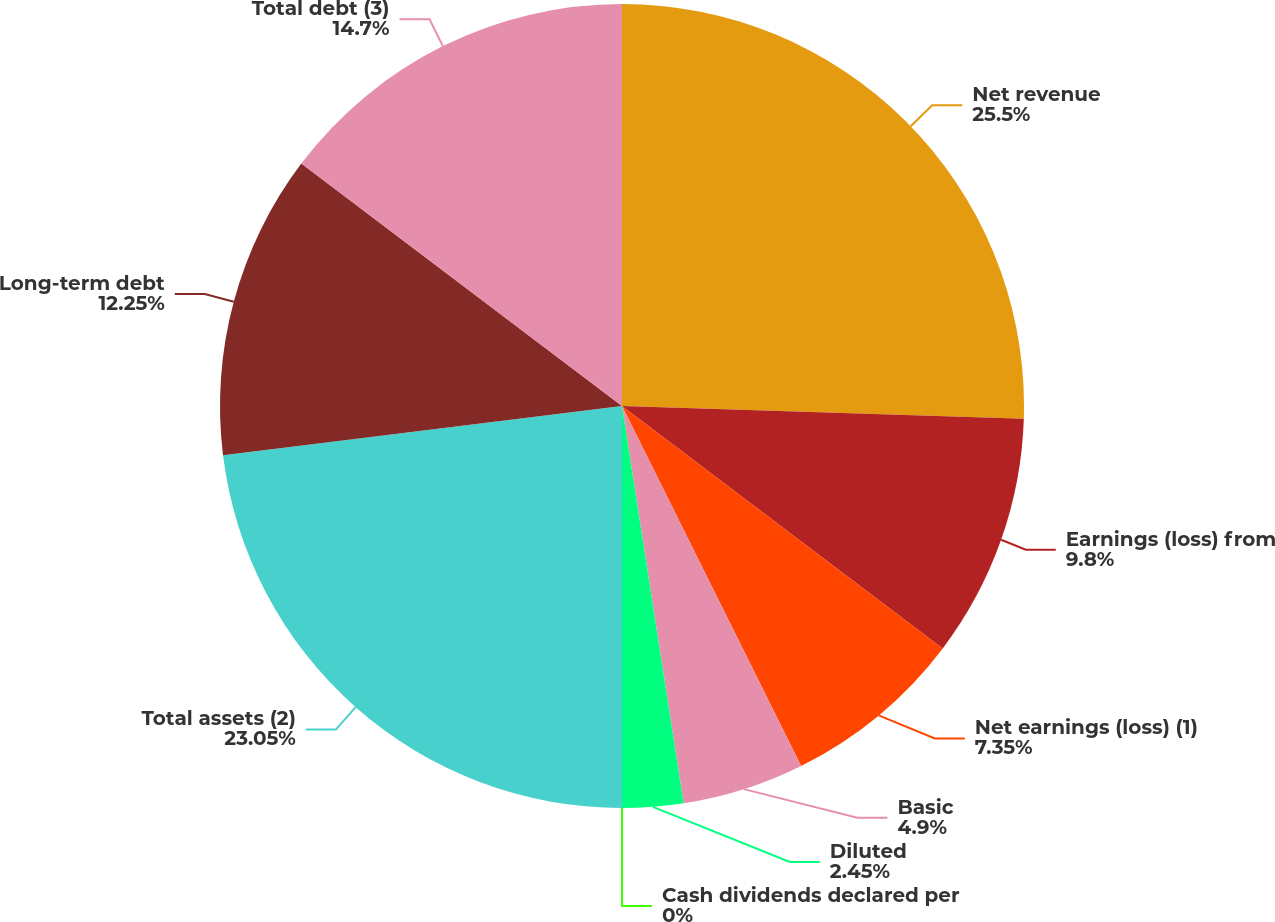Convert chart. <chart><loc_0><loc_0><loc_500><loc_500><pie_chart><fcel>Net revenue<fcel>Earnings (loss) from<fcel>Net earnings (loss) (1)<fcel>Basic<fcel>Diluted<fcel>Cash dividends declared per<fcel>Total assets (2)<fcel>Long-term debt<fcel>Total debt (3)<nl><fcel>25.5%<fcel>9.8%<fcel>7.35%<fcel>4.9%<fcel>2.45%<fcel>0.0%<fcel>23.05%<fcel>12.25%<fcel>14.7%<nl></chart> 